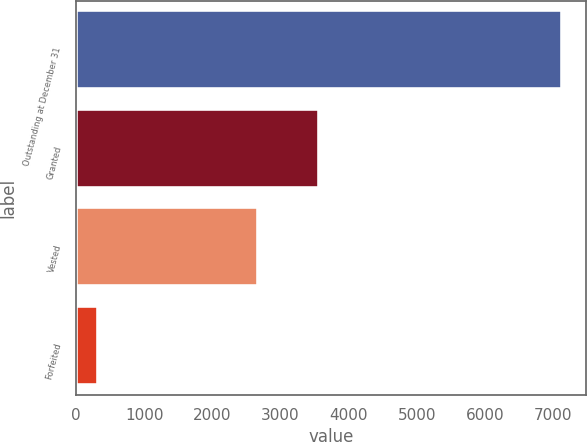Convert chart. <chart><loc_0><loc_0><loc_500><loc_500><bar_chart><fcel>Outstanding at December 31<fcel>Granted<fcel>Vested<fcel>Forfeited<nl><fcel>7124<fcel>3570<fcel>2665<fcel>313<nl></chart> 